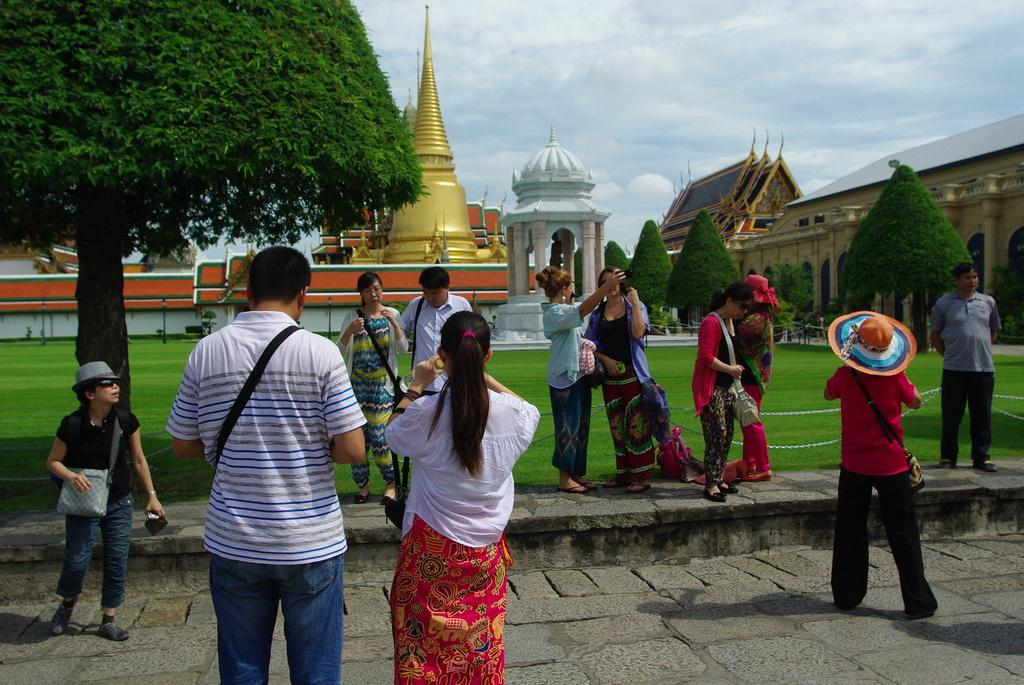What is happening in the image? There are persons standing on the floor in the image. What can be seen in the foreground of the image? Trees and the ground are visible in the foreground of the image, along with a chain. What type of structures are visible in the image? Buildings are visible in the image. What is visible in the background of the image? The sky is visible in the image, with clouds present. Can you tell me how many jellyfish are swimming in the sky in the image? There are no jellyfish present in the image; it features persons standing on the floor, trees, the ground, a chain, buildings, and the sky with clouds. What type of legal advice is the lawyer providing in the image? There is no lawyer present in the image; it features persons standing on the floor, trees, the ground, a chain, buildings, and the sky with clouds. 